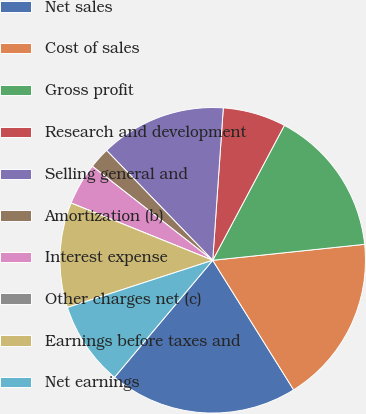<chart> <loc_0><loc_0><loc_500><loc_500><pie_chart><fcel>Net sales<fcel>Cost of sales<fcel>Gross profit<fcel>Research and development<fcel>Selling general and<fcel>Amortization (b)<fcel>Interest expense<fcel>Other charges net (c)<fcel>Earnings before taxes and<fcel>Net earnings<nl><fcel>20.0%<fcel>17.78%<fcel>15.56%<fcel>6.67%<fcel>13.33%<fcel>2.22%<fcel>4.44%<fcel>0.0%<fcel>11.11%<fcel>8.89%<nl></chart> 